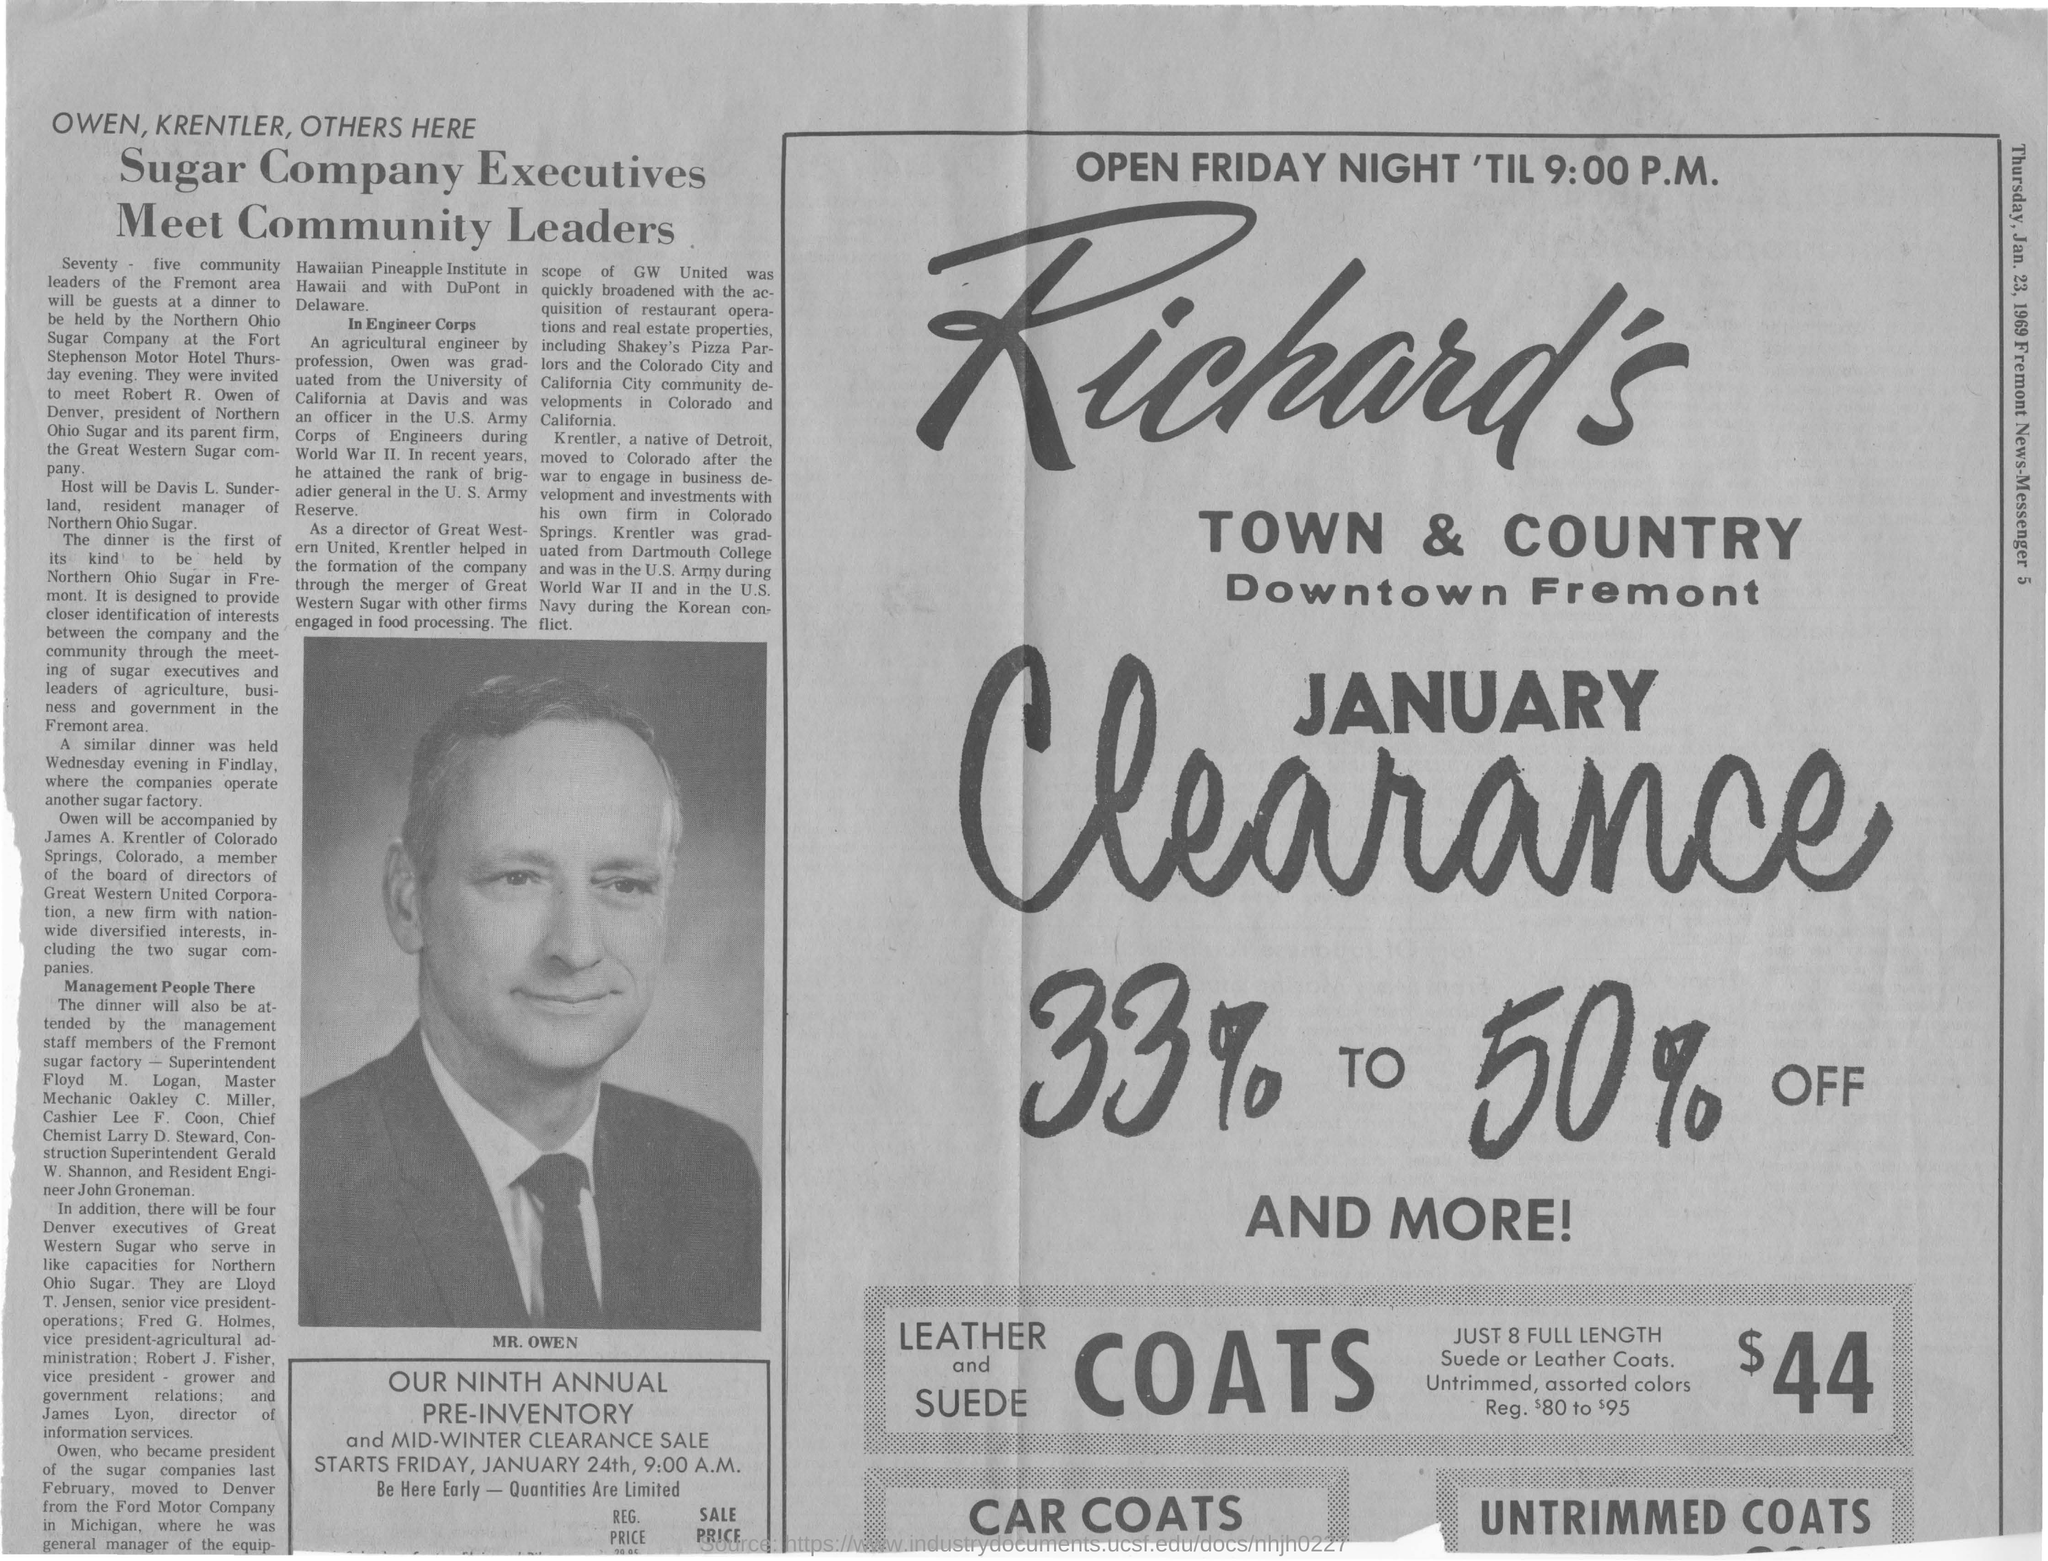Sugar Company Executives Meet whom?
Provide a succinct answer. Community Leaders. How many community leaders of the Fremont area will be guests at dinner?
Your response must be concise. Seventy - five. Owen was graduated from which university?
Provide a succinct answer. University of California at Davis. 